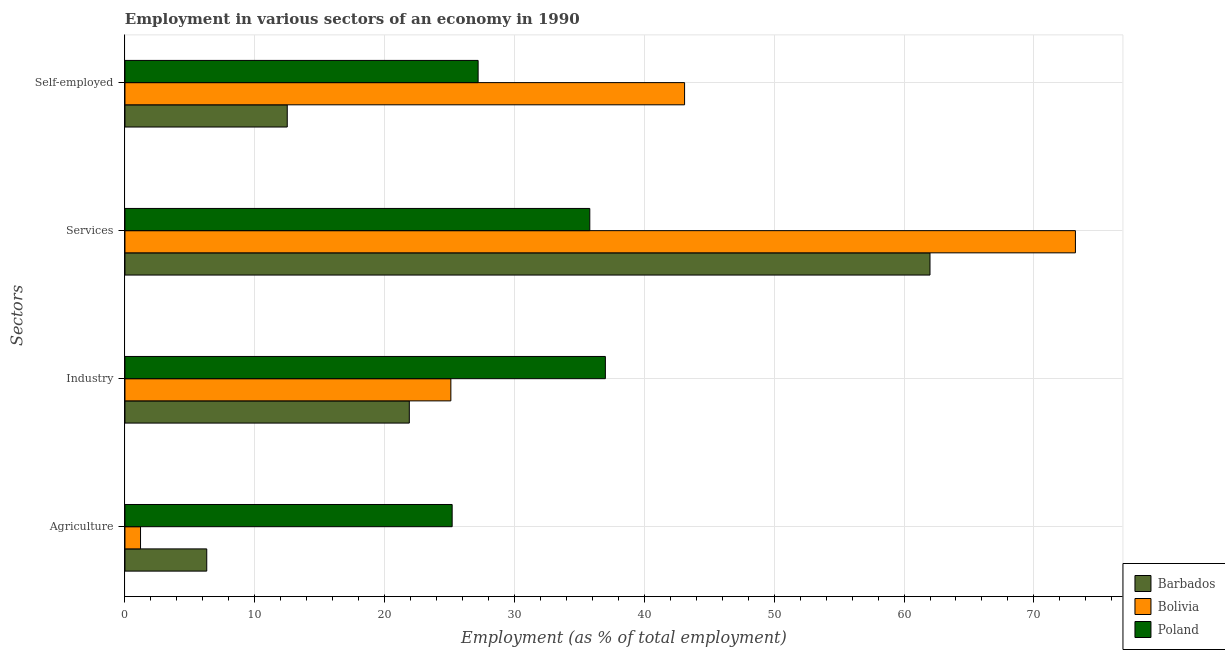How many groups of bars are there?
Offer a very short reply. 4. Are the number of bars per tick equal to the number of legend labels?
Make the answer very short. Yes. Are the number of bars on each tick of the Y-axis equal?
Offer a terse response. Yes. How many bars are there on the 4th tick from the top?
Ensure brevity in your answer.  3. What is the label of the 2nd group of bars from the top?
Offer a very short reply. Services. What is the percentage of workers in agriculture in Bolivia?
Ensure brevity in your answer.  1.2. Across all countries, what is the maximum percentage of workers in agriculture?
Offer a terse response. 25.2. Across all countries, what is the minimum percentage of workers in services?
Offer a terse response. 35.8. In which country was the percentage of workers in services maximum?
Offer a very short reply. Bolivia. In which country was the percentage of self employed workers minimum?
Your response must be concise. Barbados. What is the total percentage of workers in industry in the graph?
Provide a succinct answer. 84. What is the difference between the percentage of self employed workers in Bolivia and that in Poland?
Offer a terse response. 15.9. What is the difference between the percentage of self employed workers in Bolivia and the percentage of workers in agriculture in Barbados?
Your answer should be compact. 36.8. What is the average percentage of self employed workers per country?
Give a very brief answer. 27.6. What is the difference between the percentage of workers in industry and percentage of workers in agriculture in Bolivia?
Your answer should be compact. 23.9. What is the ratio of the percentage of workers in services in Barbados to that in Poland?
Offer a terse response. 1.73. Is the percentage of workers in industry in Barbados less than that in Poland?
Keep it short and to the point. Yes. Is the difference between the percentage of workers in agriculture in Barbados and Poland greater than the difference between the percentage of self employed workers in Barbados and Poland?
Your response must be concise. No. What is the difference between the highest and the second highest percentage of workers in industry?
Make the answer very short. 11.9. What is the difference between the highest and the lowest percentage of workers in services?
Provide a succinct answer. 37.4. In how many countries, is the percentage of self employed workers greater than the average percentage of self employed workers taken over all countries?
Your answer should be compact. 1. Is the sum of the percentage of workers in services in Poland and Barbados greater than the maximum percentage of workers in agriculture across all countries?
Your response must be concise. Yes. Is it the case that in every country, the sum of the percentage of workers in industry and percentage of workers in agriculture is greater than the sum of percentage of workers in services and percentage of self employed workers?
Offer a terse response. No. What does the 2nd bar from the bottom in Services represents?
Provide a short and direct response. Bolivia. Are all the bars in the graph horizontal?
Your answer should be very brief. Yes. How many countries are there in the graph?
Offer a very short reply. 3. What is the difference between two consecutive major ticks on the X-axis?
Ensure brevity in your answer.  10. Are the values on the major ticks of X-axis written in scientific E-notation?
Provide a short and direct response. No. Does the graph contain any zero values?
Ensure brevity in your answer.  No. Where does the legend appear in the graph?
Your response must be concise. Bottom right. What is the title of the graph?
Your answer should be compact. Employment in various sectors of an economy in 1990. Does "Venezuela" appear as one of the legend labels in the graph?
Your answer should be compact. No. What is the label or title of the X-axis?
Provide a succinct answer. Employment (as % of total employment). What is the label or title of the Y-axis?
Your response must be concise. Sectors. What is the Employment (as % of total employment) of Barbados in Agriculture?
Your answer should be very brief. 6.3. What is the Employment (as % of total employment) in Bolivia in Agriculture?
Keep it short and to the point. 1.2. What is the Employment (as % of total employment) of Poland in Agriculture?
Give a very brief answer. 25.2. What is the Employment (as % of total employment) of Barbados in Industry?
Keep it short and to the point. 21.9. What is the Employment (as % of total employment) of Bolivia in Industry?
Offer a very short reply. 25.1. What is the Employment (as % of total employment) of Poland in Industry?
Give a very brief answer. 37. What is the Employment (as % of total employment) in Barbados in Services?
Provide a short and direct response. 62. What is the Employment (as % of total employment) of Bolivia in Services?
Keep it short and to the point. 73.2. What is the Employment (as % of total employment) of Poland in Services?
Provide a succinct answer. 35.8. What is the Employment (as % of total employment) of Barbados in Self-employed?
Provide a succinct answer. 12.5. What is the Employment (as % of total employment) in Bolivia in Self-employed?
Provide a succinct answer. 43.1. What is the Employment (as % of total employment) in Poland in Self-employed?
Ensure brevity in your answer.  27.2. Across all Sectors, what is the maximum Employment (as % of total employment) in Barbados?
Your answer should be very brief. 62. Across all Sectors, what is the maximum Employment (as % of total employment) of Bolivia?
Ensure brevity in your answer.  73.2. Across all Sectors, what is the maximum Employment (as % of total employment) of Poland?
Your answer should be very brief. 37. Across all Sectors, what is the minimum Employment (as % of total employment) in Barbados?
Your answer should be very brief. 6.3. Across all Sectors, what is the minimum Employment (as % of total employment) of Bolivia?
Provide a short and direct response. 1.2. Across all Sectors, what is the minimum Employment (as % of total employment) in Poland?
Your answer should be compact. 25.2. What is the total Employment (as % of total employment) in Barbados in the graph?
Ensure brevity in your answer.  102.7. What is the total Employment (as % of total employment) of Bolivia in the graph?
Your answer should be very brief. 142.6. What is the total Employment (as % of total employment) of Poland in the graph?
Offer a very short reply. 125.2. What is the difference between the Employment (as % of total employment) of Barbados in Agriculture and that in Industry?
Make the answer very short. -15.6. What is the difference between the Employment (as % of total employment) of Bolivia in Agriculture and that in Industry?
Your answer should be very brief. -23.9. What is the difference between the Employment (as % of total employment) in Poland in Agriculture and that in Industry?
Make the answer very short. -11.8. What is the difference between the Employment (as % of total employment) of Barbados in Agriculture and that in Services?
Ensure brevity in your answer.  -55.7. What is the difference between the Employment (as % of total employment) of Bolivia in Agriculture and that in Services?
Keep it short and to the point. -72. What is the difference between the Employment (as % of total employment) in Bolivia in Agriculture and that in Self-employed?
Make the answer very short. -41.9. What is the difference between the Employment (as % of total employment) of Barbados in Industry and that in Services?
Provide a succinct answer. -40.1. What is the difference between the Employment (as % of total employment) of Bolivia in Industry and that in Services?
Provide a short and direct response. -48.1. What is the difference between the Employment (as % of total employment) in Bolivia in Industry and that in Self-employed?
Offer a terse response. -18. What is the difference between the Employment (as % of total employment) of Barbados in Services and that in Self-employed?
Offer a very short reply. 49.5. What is the difference between the Employment (as % of total employment) in Bolivia in Services and that in Self-employed?
Provide a short and direct response. 30.1. What is the difference between the Employment (as % of total employment) of Poland in Services and that in Self-employed?
Your answer should be very brief. 8.6. What is the difference between the Employment (as % of total employment) in Barbados in Agriculture and the Employment (as % of total employment) in Bolivia in Industry?
Keep it short and to the point. -18.8. What is the difference between the Employment (as % of total employment) of Barbados in Agriculture and the Employment (as % of total employment) of Poland in Industry?
Provide a short and direct response. -30.7. What is the difference between the Employment (as % of total employment) of Bolivia in Agriculture and the Employment (as % of total employment) of Poland in Industry?
Ensure brevity in your answer.  -35.8. What is the difference between the Employment (as % of total employment) in Barbados in Agriculture and the Employment (as % of total employment) in Bolivia in Services?
Provide a short and direct response. -66.9. What is the difference between the Employment (as % of total employment) of Barbados in Agriculture and the Employment (as % of total employment) of Poland in Services?
Provide a succinct answer. -29.5. What is the difference between the Employment (as % of total employment) of Bolivia in Agriculture and the Employment (as % of total employment) of Poland in Services?
Keep it short and to the point. -34.6. What is the difference between the Employment (as % of total employment) of Barbados in Agriculture and the Employment (as % of total employment) of Bolivia in Self-employed?
Your answer should be compact. -36.8. What is the difference between the Employment (as % of total employment) of Barbados in Agriculture and the Employment (as % of total employment) of Poland in Self-employed?
Your answer should be compact. -20.9. What is the difference between the Employment (as % of total employment) in Barbados in Industry and the Employment (as % of total employment) in Bolivia in Services?
Keep it short and to the point. -51.3. What is the difference between the Employment (as % of total employment) in Bolivia in Industry and the Employment (as % of total employment) in Poland in Services?
Your answer should be compact. -10.7. What is the difference between the Employment (as % of total employment) in Barbados in Industry and the Employment (as % of total employment) in Bolivia in Self-employed?
Your answer should be compact. -21.2. What is the difference between the Employment (as % of total employment) of Barbados in Industry and the Employment (as % of total employment) of Poland in Self-employed?
Keep it short and to the point. -5.3. What is the difference between the Employment (as % of total employment) in Barbados in Services and the Employment (as % of total employment) in Bolivia in Self-employed?
Make the answer very short. 18.9. What is the difference between the Employment (as % of total employment) of Barbados in Services and the Employment (as % of total employment) of Poland in Self-employed?
Keep it short and to the point. 34.8. What is the average Employment (as % of total employment) in Barbados per Sectors?
Offer a very short reply. 25.68. What is the average Employment (as % of total employment) of Bolivia per Sectors?
Provide a short and direct response. 35.65. What is the average Employment (as % of total employment) in Poland per Sectors?
Offer a terse response. 31.3. What is the difference between the Employment (as % of total employment) of Barbados and Employment (as % of total employment) of Poland in Agriculture?
Give a very brief answer. -18.9. What is the difference between the Employment (as % of total employment) in Bolivia and Employment (as % of total employment) in Poland in Agriculture?
Make the answer very short. -24. What is the difference between the Employment (as % of total employment) in Barbados and Employment (as % of total employment) in Poland in Industry?
Your response must be concise. -15.1. What is the difference between the Employment (as % of total employment) of Barbados and Employment (as % of total employment) of Bolivia in Services?
Your response must be concise. -11.2. What is the difference between the Employment (as % of total employment) in Barbados and Employment (as % of total employment) in Poland in Services?
Keep it short and to the point. 26.2. What is the difference between the Employment (as % of total employment) of Bolivia and Employment (as % of total employment) of Poland in Services?
Keep it short and to the point. 37.4. What is the difference between the Employment (as % of total employment) of Barbados and Employment (as % of total employment) of Bolivia in Self-employed?
Make the answer very short. -30.6. What is the difference between the Employment (as % of total employment) in Barbados and Employment (as % of total employment) in Poland in Self-employed?
Provide a short and direct response. -14.7. What is the difference between the Employment (as % of total employment) of Bolivia and Employment (as % of total employment) of Poland in Self-employed?
Give a very brief answer. 15.9. What is the ratio of the Employment (as % of total employment) of Barbados in Agriculture to that in Industry?
Make the answer very short. 0.29. What is the ratio of the Employment (as % of total employment) of Bolivia in Agriculture to that in Industry?
Make the answer very short. 0.05. What is the ratio of the Employment (as % of total employment) in Poland in Agriculture to that in Industry?
Provide a short and direct response. 0.68. What is the ratio of the Employment (as % of total employment) of Barbados in Agriculture to that in Services?
Your answer should be very brief. 0.1. What is the ratio of the Employment (as % of total employment) in Bolivia in Agriculture to that in Services?
Offer a terse response. 0.02. What is the ratio of the Employment (as % of total employment) of Poland in Agriculture to that in Services?
Provide a short and direct response. 0.7. What is the ratio of the Employment (as % of total employment) in Barbados in Agriculture to that in Self-employed?
Make the answer very short. 0.5. What is the ratio of the Employment (as % of total employment) in Bolivia in Agriculture to that in Self-employed?
Keep it short and to the point. 0.03. What is the ratio of the Employment (as % of total employment) in Poland in Agriculture to that in Self-employed?
Provide a short and direct response. 0.93. What is the ratio of the Employment (as % of total employment) of Barbados in Industry to that in Services?
Provide a short and direct response. 0.35. What is the ratio of the Employment (as % of total employment) of Bolivia in Industry to that in Services?
Keep it short and to the point. 0.34. What is the ratio of the Employment (as % of total employment) of Poland in Industry to that in Services?
Offer a very short reply. 1.03. What is the ratio of the Employment (as % of total employment) in Barbados in Industry to that in Self-employed?
Your answer should be very brief. 1.75. What is the ratio of the Employment (as % of total employment) in Bolivia in Industry to that in Self-employed?
Provide a succinct answer. 0.58. What is the ratio of the Employment (as % of total employment) of Poland in Industry to that in Self-employed?
Keep it short and to the point. 1.36. What is the ratio of the Employment (as % of total employment) in Barbados in Services to that in Self-employed?
Your answer should be compact. 4.96. What is the ratio of the Employment (as % of total employment) of Bolivia in Services to that in Self-employed?
Give a very brief answer. 1.7. What is the ratio of the Employment (as % of total employment) in Poland in Services to that in Self-employed?
Offer a very short reply. 1.32. What is the difference between the highest and the second highest Employment (as % of total employment) in Barbados?
Provide a succinct answer. 40.1. What is the difference between the highest and the second highest Employment (as % of total employment) of Bolivia?
Ensure brevity in your answer.  30.1. What is the difference between the highest and the second highest Employment (as % of total employment) of Poland?
Provide a succinct answer. 1.2. What is the difference between the highest and the lowest Employment (as % of total employment) in Barbados?
Offer a terse response. 55.7. What is the difference between the highest and the lowest Employment (as % of total employment) in Poland?
Your response must be concise. 11.8. 